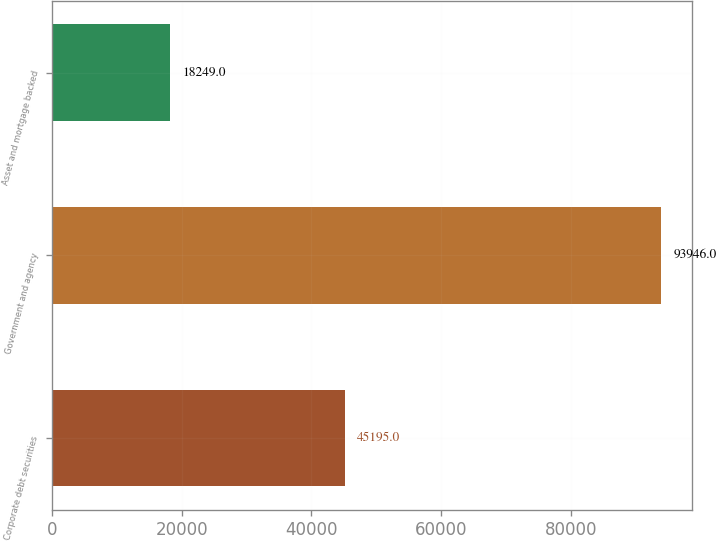<chart> <loc_0><loc_0><loc_500><loc_500><bar_chart><fcel>Corporate debt securities<fcel>Government and agency<fcel>Asset and mortgage backed<nl><fcel>45195<fcel>93946<fcel>18249<nl></chart> 